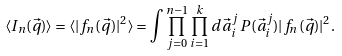Convert formula to latex. <formula><loc_0><loc_0><loc_500><loc_500>\langle I _ { n } ( { \vec { q } } ) \rangle = \langle | f _ { n } ( { \vec { q } } ) | ^ { 2 } \rangle = \int \prod _ { j = 0 } ^ { n - 1 } \prod _ { i = 1 } ^ { k } d { \vec { a } } _ { i } ^ { j } \, P ( { \vec { a } } _ { i } ^ { j } ) | f _ { n } ( { \vec { q } } ) | ^ { 2 } .</formula> 